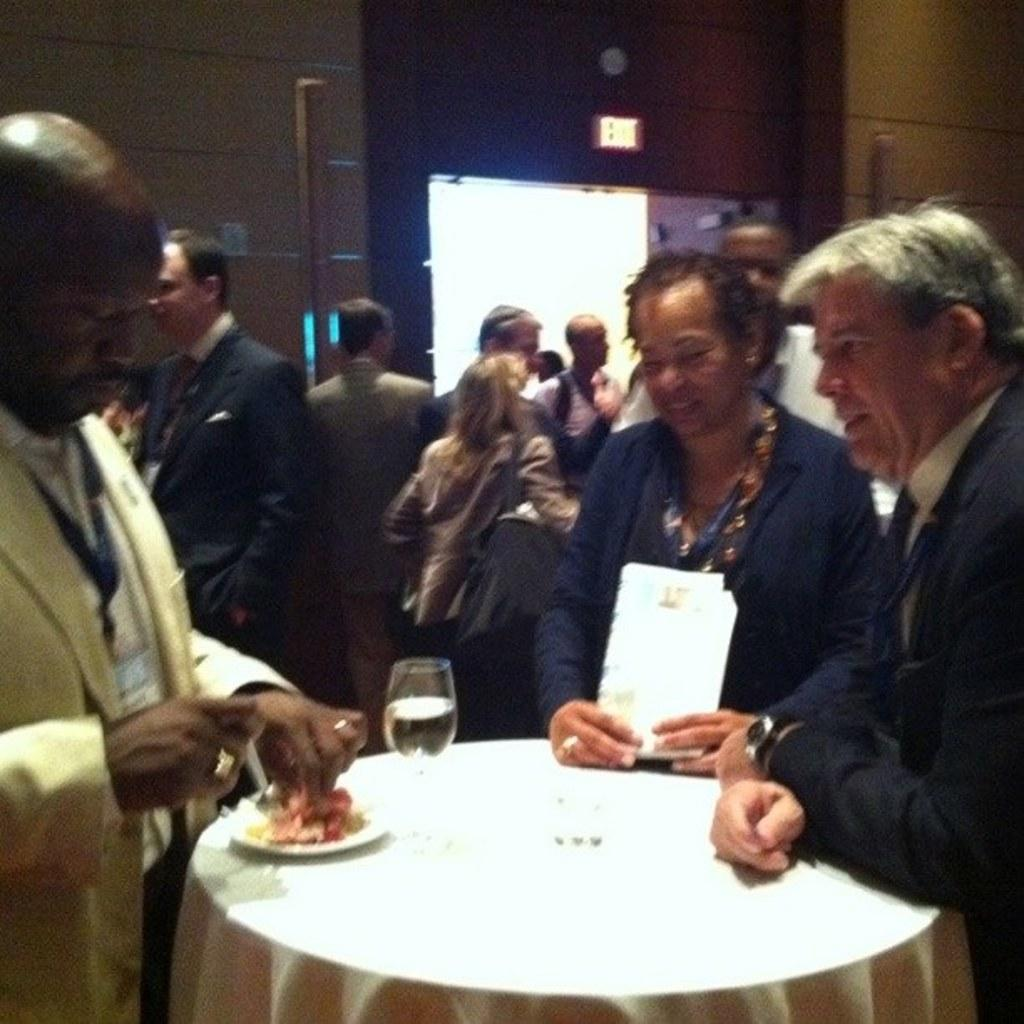How many people are in the picture? There are people in the picture, specifically three people. What are the people doing in the image? The three people are around a single table. What objects can be seen on the table? There is a glass and a plate on the table. What type of lizards can be seen on the table in the image? There are no lizards present in the image; the objects on the table are a glass and a plate. 